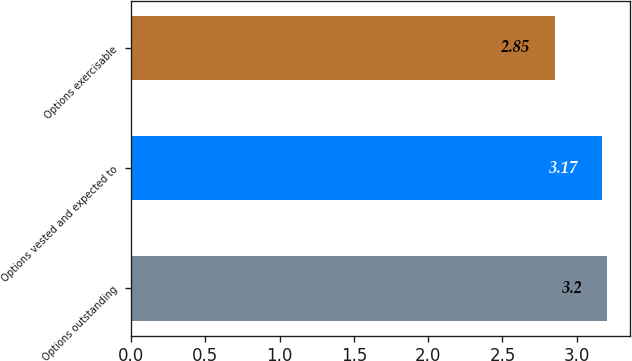Convert chart to OTSL. <chart><loc_0><loc_0><loc_500><loc_500><bar_chart><fcel>Options outstanding<fcel>Options vested and expected to<fcel>Options exercisable<nl><fcel>3.2<fcel>3.17<fcel>2.85<nl></chart> 